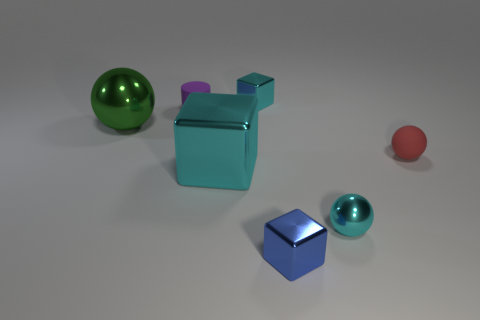There is a cyan metal thing right of the tiny cyan block; does it have the same shape as the small blue metal object? no 